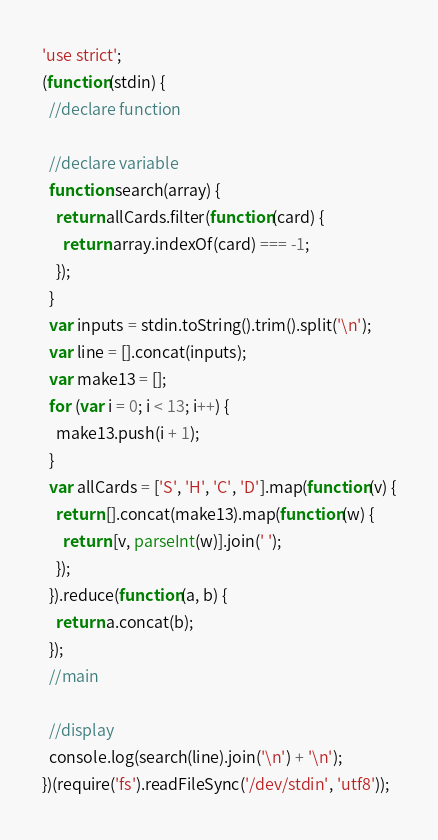<code> <loc_0><loc_0><loc_500><loc_500><_JavaScript_>'use strict';
(function(stdin) {
  //declare function

  //declare variable
  function search(array) {
    return allCards.filter(function(card) {
      return array.indexOf(card) === -1;
    });
  }
  var inputs = stdin.toString().trim().split('\n');
  var line = [].concat(inputs);
  var make13 = [];
  for (var i = 0; i < 13; i++) {
    make13.push(i + 1);
  }
  var allCards = ['S', 'H', 'C', 'D'].map(function(v) {
    return [].concat(make13).map(function(w) {
      return [v, parseInt(w)].join(' ');
    });
  }).reduce(function(a, b) {
    return a.concat(b);
  });
  //main

  //display
  console.log(search(line).join('\n') + '\n');
})(require('fs').readFileSync('/dev/stdin', 'utf8'));</code> 